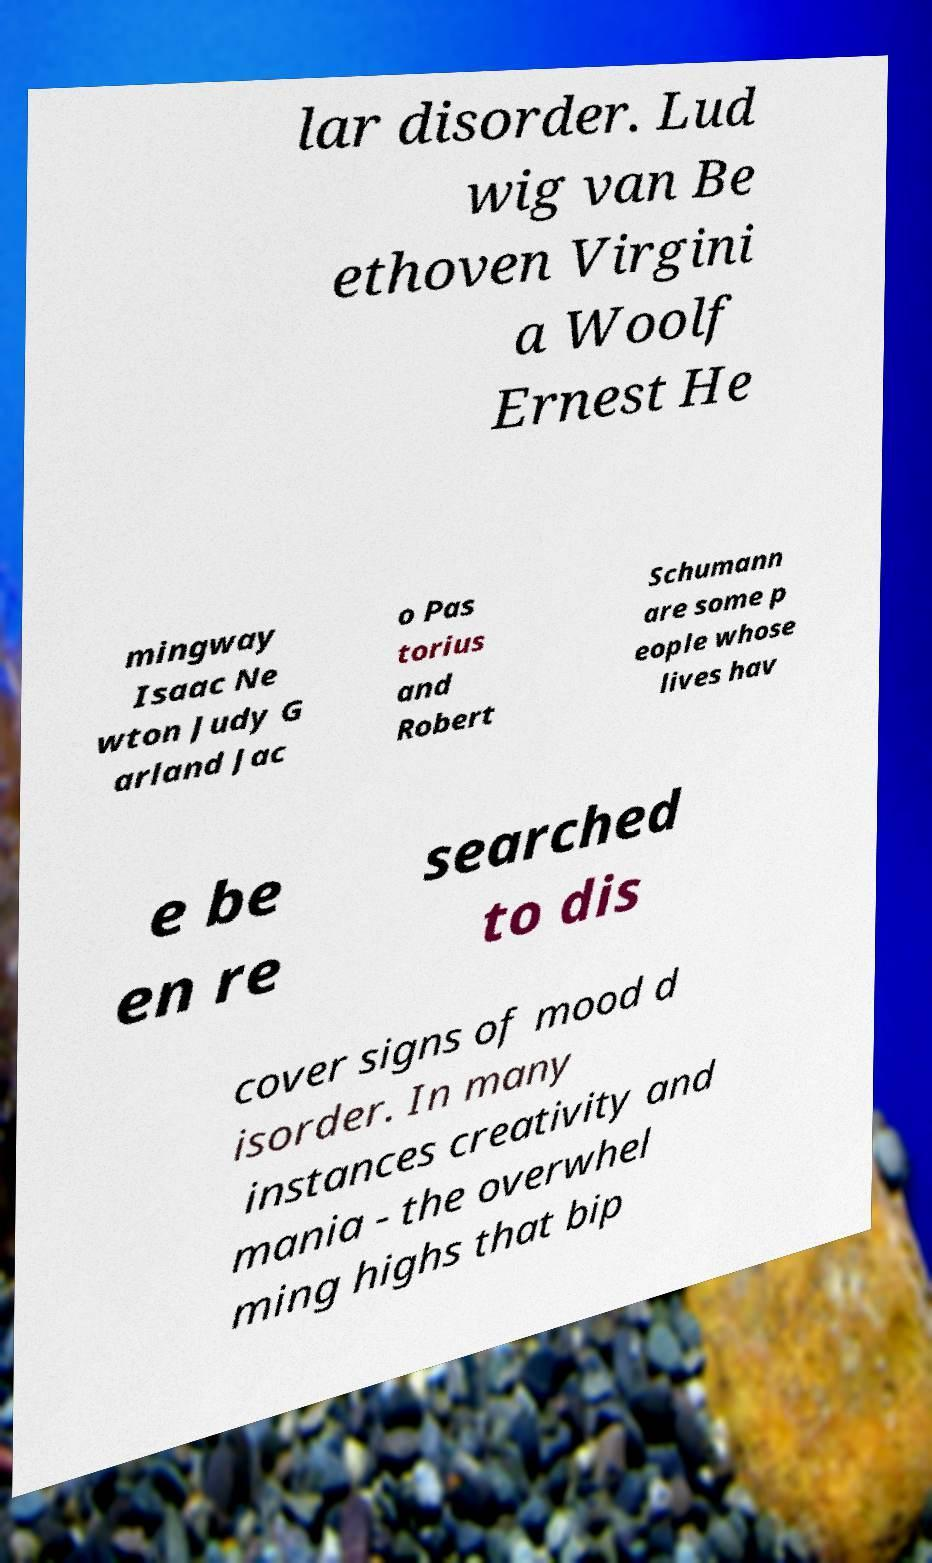Can you accurately transcribe the text from the provided image for me? lar disorder. Lud wig van Be ethoven Virgini a Woolf Ernest He mingway Isaac Ne wton Judy G arland Jac o Pas torius and Robert Schumann are some p eople whose lives hav e be en re searched to dis cover signs of mood d isorder. In many instances creativity and mania - the overwhel ming highs that bip 